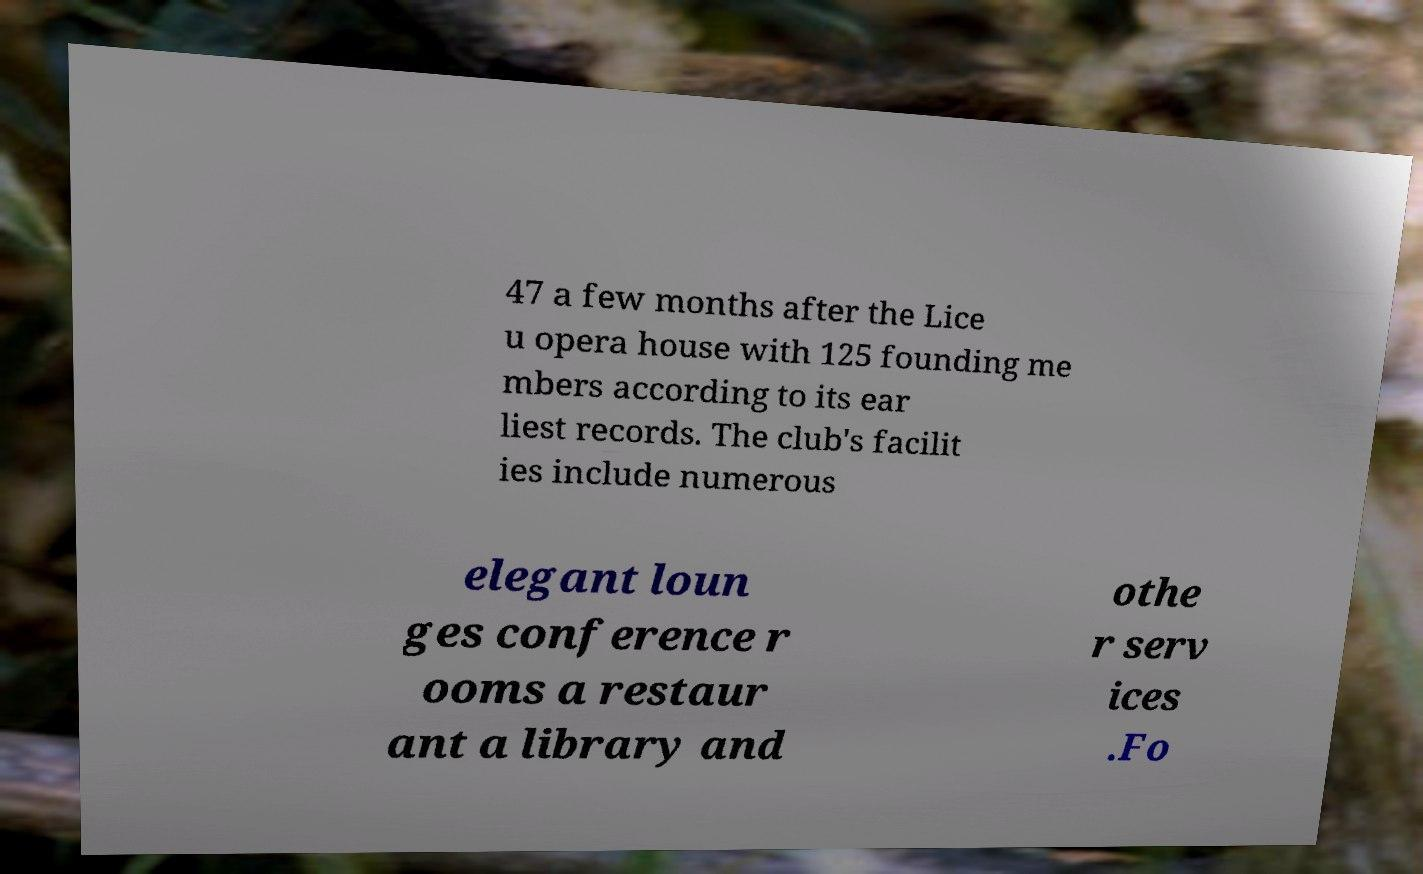Can you accurately transcribe the text from the provided image for me? 47 a few months after the Lice u opera house with 125 founding me mbers according to its ear liest records. The club's facilit ies include numerous elegant loun ges conference r ooms a restaur ant a library and othe r serv ices .Fo 